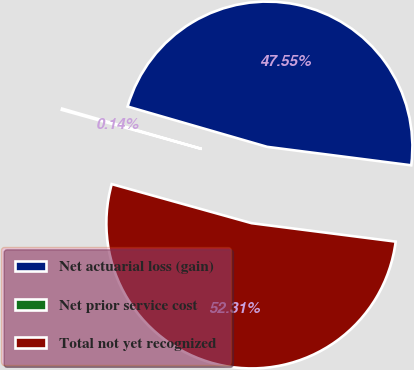Convert chart to OTSL. <chart><loc_0><loc_0><loc_500><loc_500><pie_chart><fcel>Net actuarial loss (gain)<fcel>Net prior service cost<fcel>Total not yet recognized<nl><fcel>47.55%<fcel>0.14%<fcel>52.31%<nl></chart> 